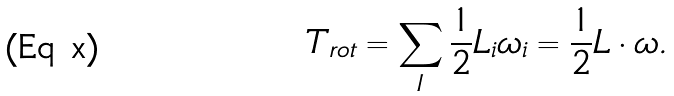Convert formula to latex. <formula><loc_0><loc_0><loc_500><loc_500>T _ { r o t } = \sum _ { I } \frac { 1 } { 2 } L _ { i } \omega _ { i } = \frac { 1 } { 2 } { L \cdot \omega } .</formula> 